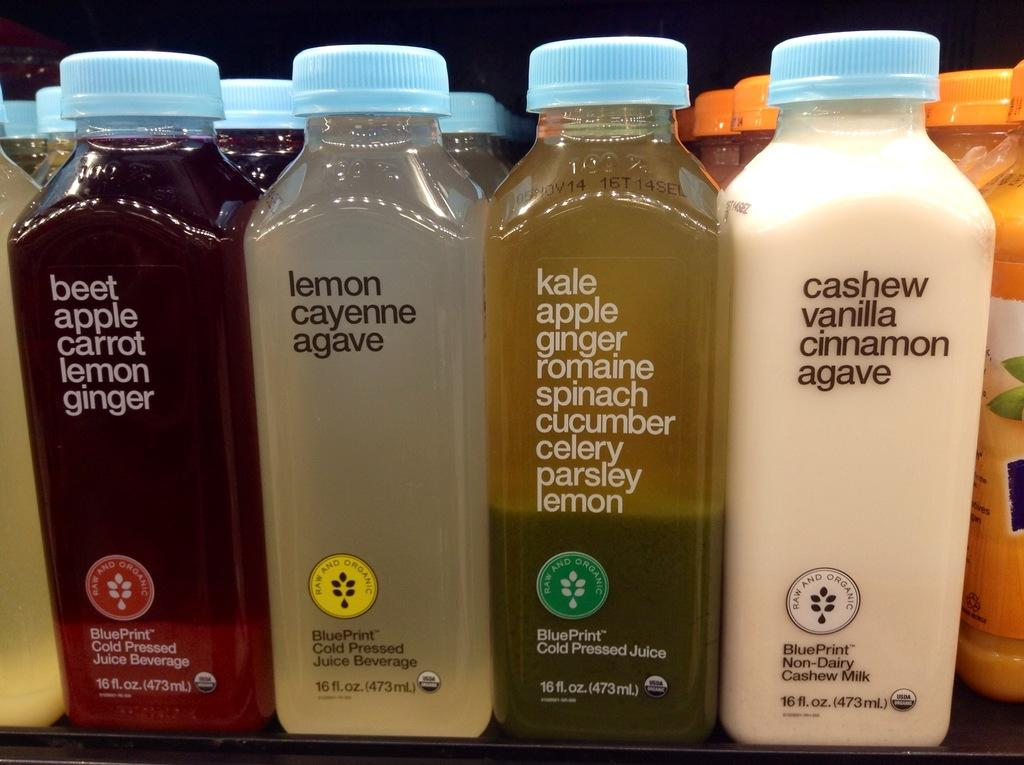<image>
Create a compact narrative representing the image presented. four bottles of juice, one of which is cashew, vanilla, cinnamon and agave 